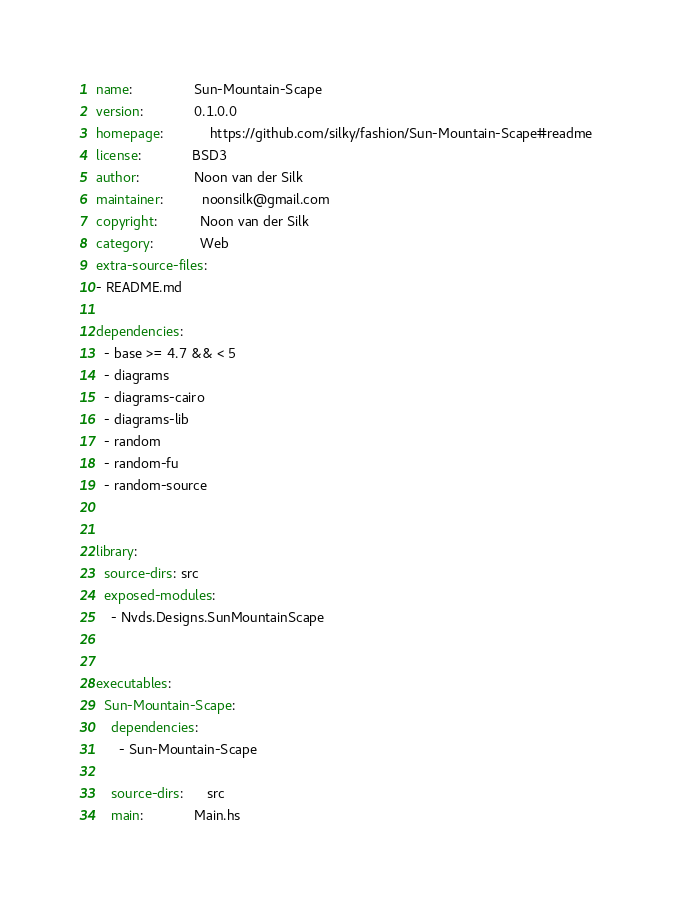<code> <loc_0><loc_0><loc_500><loc_500><_YAML_>name:                Sun-Mountain-Scape
version:             0.1.0.0
homepage:            https://github.com/silky/fashion/Sun-Mountain-Scape#readme
license:             BSD3
author:              Noon van der Silk
maintainer:          noonsilk@gmail.com
copyright:           Noon van der Silk
category:            Web
extra-source-files:
- README.md

dependencies:
  - base >= 4.7 && < 5
  - diagrams
  - diagrams-cairo
  - diagrams-lib
  - random
  - random-fu
  - random-source


library:
  source-dirs: src
  exposed-modules:
    - Nvds.Designs.SunMountainScape


executables:
  Sun-Mountain-Scape:
    dependencies:
      - Sun-Mountain-Scape

    source-dirs:      src
    main:             Main.hs
</code> 